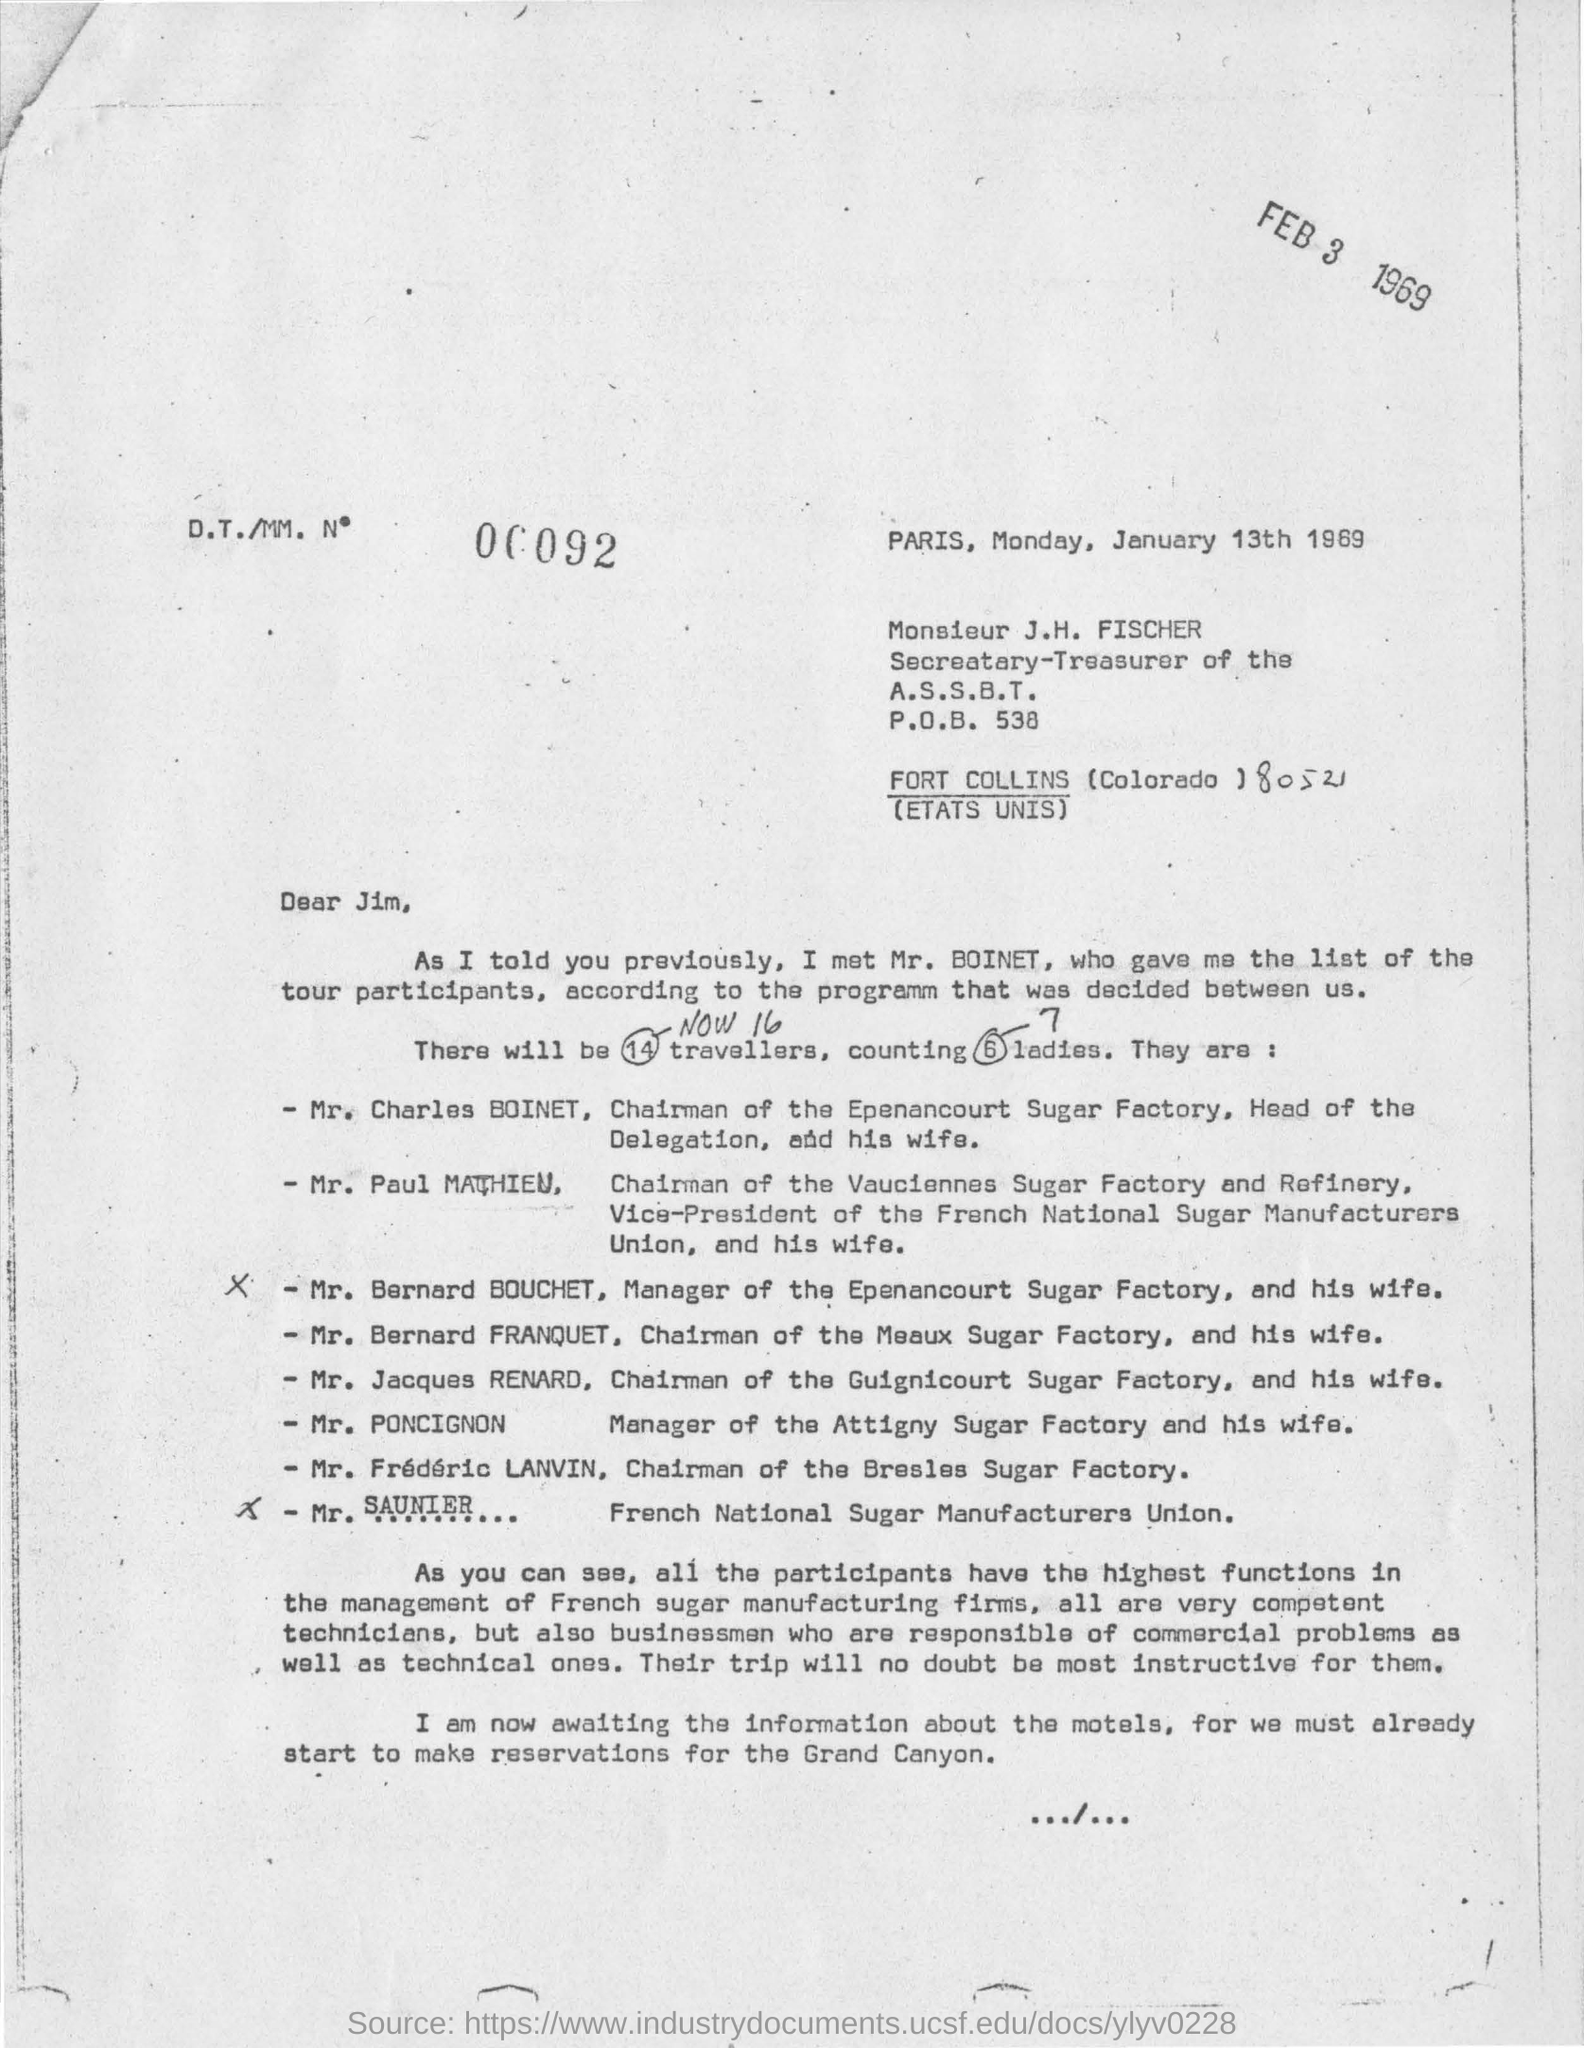Highlight a few significant elements in this photo. The secretary-treasurer of the A.S.S.B.T. is Monsieur J.H. Fischer. The list of tour participants was given by Mr. Boinet. There are 7 ladies among the 16 travelers. There are 14 travelers for the tour. The letter was written on Monday, January 13th, 1969. 